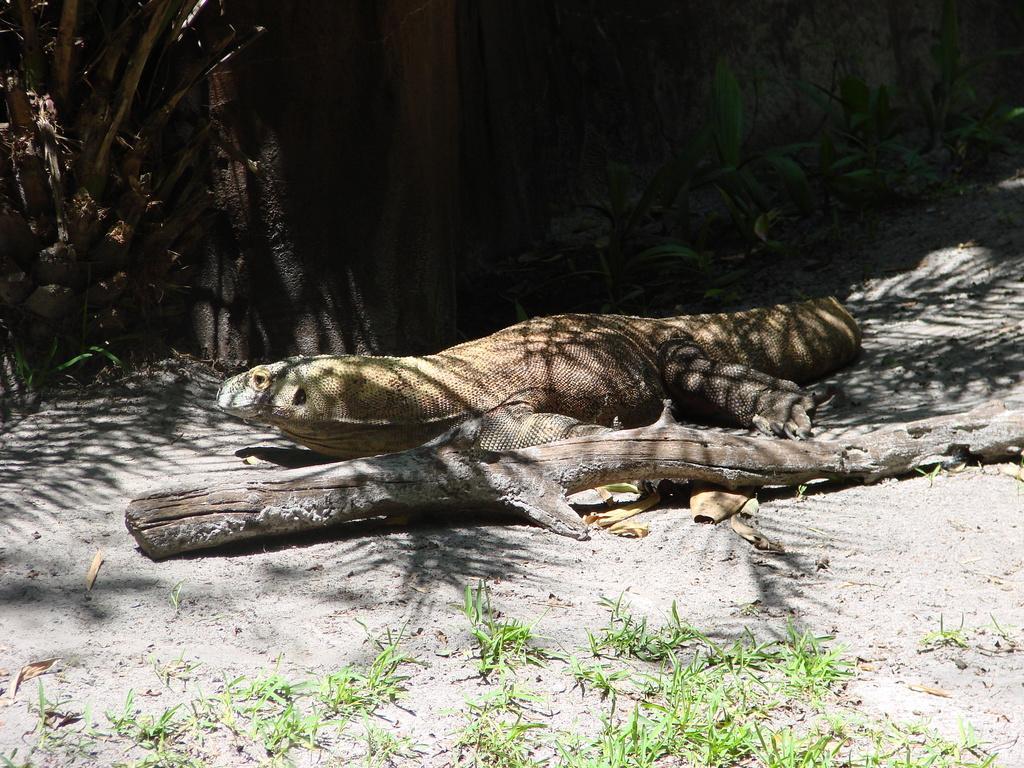How would you summarize this image in a sentence or two? The picture is taken in a zoo. In the center of the picture there is a dragon lizard. In the foreground there is grass, mud and trunk. At the top there are plants, rock and tree. It is sunny. 